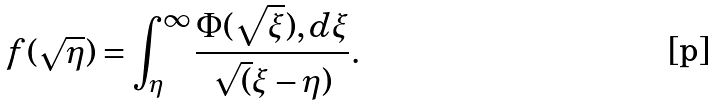Convert formula to latex. <formula><loc_0><loc_0><loc_500><loc_500>f ( \sqrt { \eta } ) = \int _ { \eta } ^ { \infty } \frac { \Phi ( \sqrt { \xi } ) , d \xi } { \sqrt { ( } \xi - \eta ) } .</formula> 